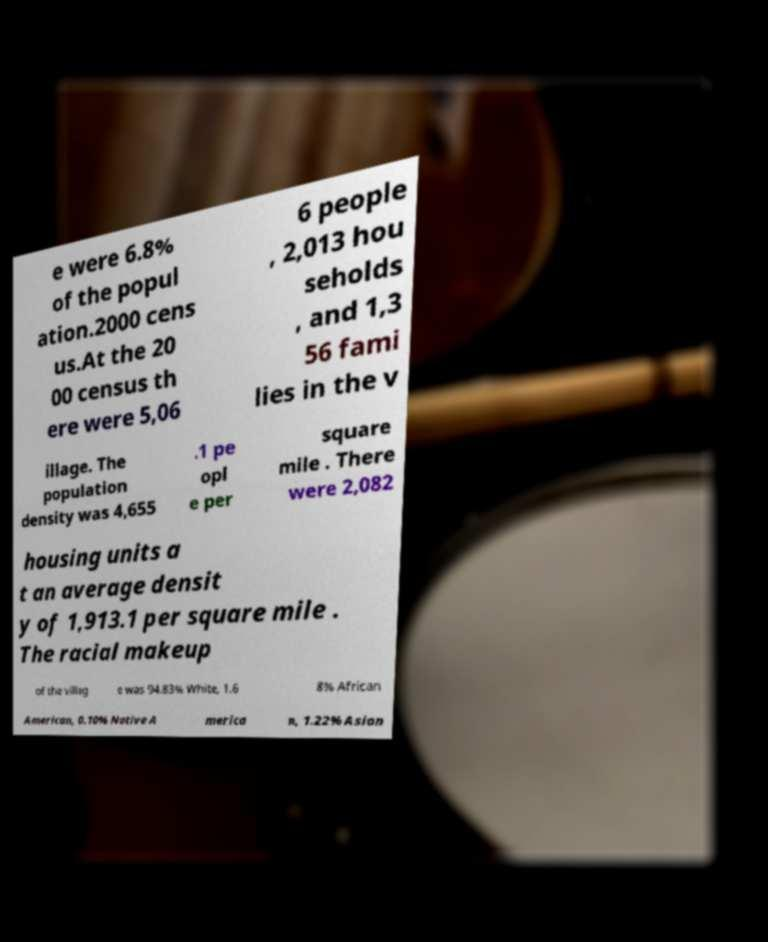Please read and relay the text visible in this image. What does it say? e were 6.8% of the popul ation.2000 cens us.At the 20 00 census th ere were 5,06 6 people , 2,013 hou seholds , and 1,3 56 fami lies in the v illage. The population density was 4,655 .1 pe opl e per square mile . There were 2,082 housing units a t an average densit y of 1,913.1 per square mile . The racial makeup of the villag e was 94.83% White, 1.6 8% African American, 0.10% Native A merica n, 1.22% Asian 